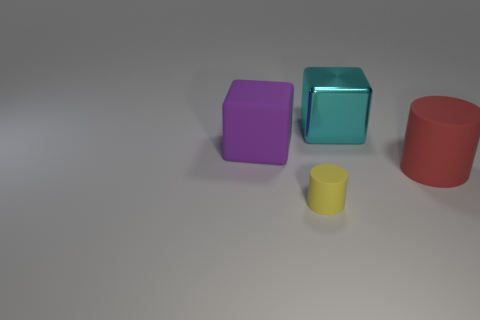What number of cyan things are big rubber cylinders or small cylinders?
Ensure brevity in your answer.  0. There is another cylinder that is made of the same material as the large red cylinder; what is its color?
Offer a very short reply. Yellow. Is the big block in front of the metallic thing made of the same material as the big block that is to the right of the large purple thing?
Ensure brevity in your answer.  No. There is a big block that is on the right side of the small object; what is its material?
Make the answer very short. Metal. There is a object on the right side of the cyan shiny cube; is it the same shape as the yellow object that is to the left of the large cyan shiny block?
Ensure brevity in your answer.  Yes. Is there a big yellow matte sphere?
Your answer should be compact. No. What is the material of the cyan object that is the same shape as the purple matte thing?
Offer a terse response. Metal. There is a small yellow cylinder; are there any matte cylinders behind it?
Make the answer very short. Yes. Do the big thing that is on the left side of the cyan metallic thing and the red thing have the same material?
Offer a terse response. Yes. There is a big purple rubber thing; what shape is it?
Offer a very short reply. Cube. 